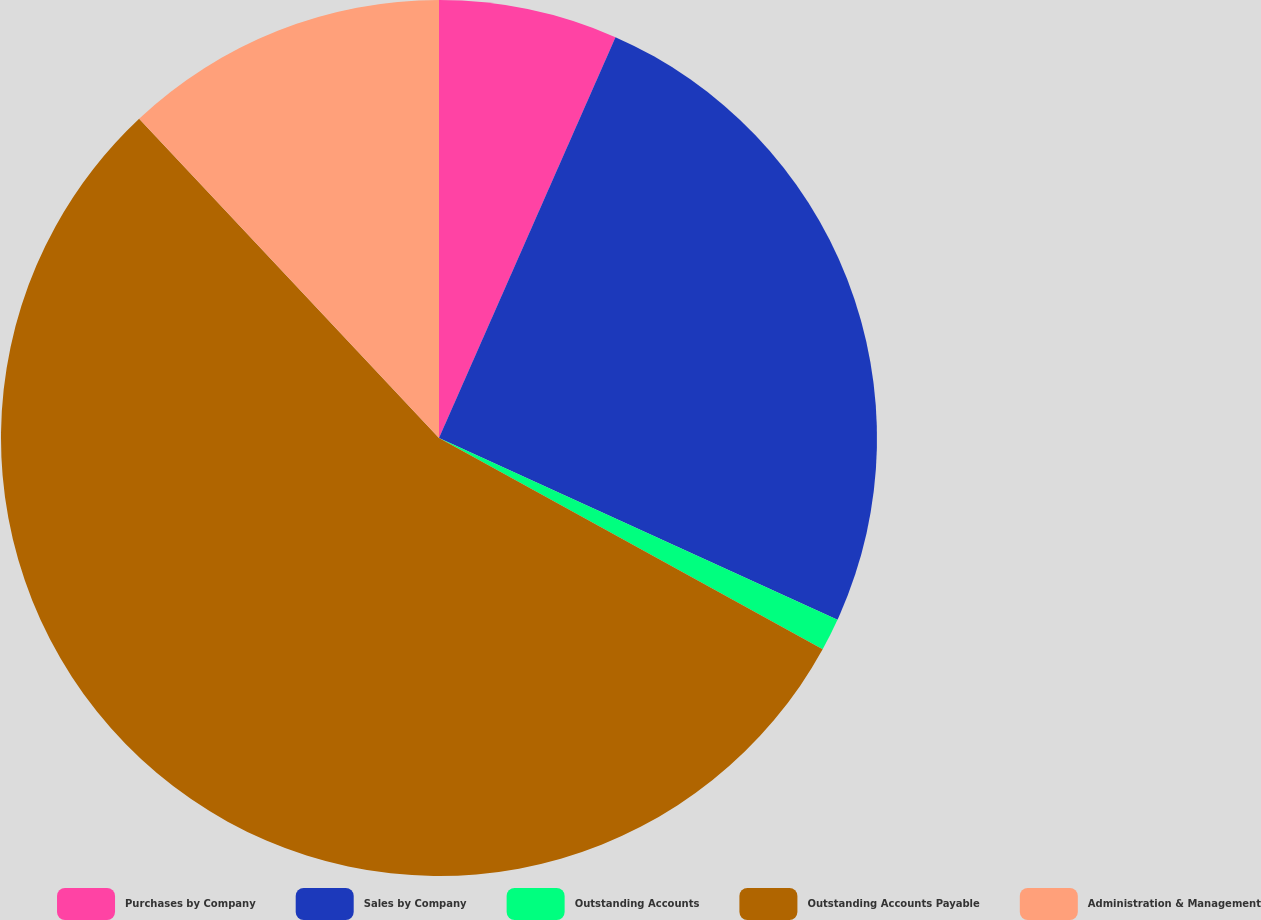Convert chart. <chart><loc_0><loc_0><loc_500><loc_500><pie_chart><fcel>Purchases by Company<fcel>Sales by Company<fcel>Outstanding Accounts<fcel>Outstanding Accounts Payable<fcel>Administration & Management<nl><fcel>6.6%<fcel>25.21%<fcel>1.2%<fcel>54.98%<fcel>12.0%<nl></chart> 